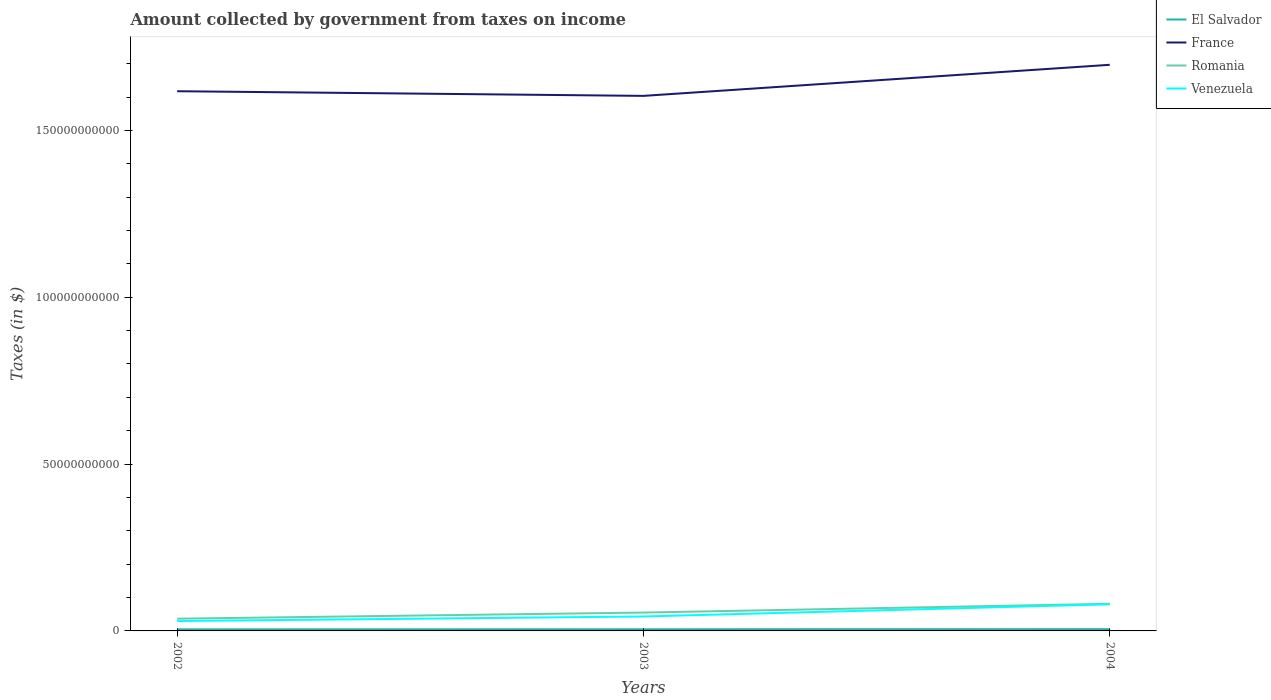Across all years, what is the maximum amount collected by government from taxes on income in El Salvador?
Make the answer very short. 4.71e+08. In which year was the amount collected by government from taxes on income in Romania maximum?
Ensure brevity in your answer.  2002. What is the total amount collected by government from taxes on income in Venezuela in the graph?
Give a very brief answer. -5.02e+09. What is the difference between the highest and the second highest amount collected by government from taxes on income in France?
Your answer should be compact. 9.31e+09. What is the difference between the highest and the lowest amount collected by government from taxes on income in Venezuela?
Give a very brief answer. 1. Is the amount collected by government from taxes on income in Romania strictly greater than the amount collected by government from taxes on income in France over the years?
Provide a short and direct response. Yes. How many lines are there?
Offer a very short reply. 4. How many years are there in the graph?
Offer a very short reply. 3. What is the difference between two consecutive major ticks on the Y-axis?
Ensure brevity in your answer.  5.00e+1. Are the values on the major ticks of Y-axis written in scientific E-notation?
Ensure brevity in your answer.  No. Where does the legend appear in the graph?
Provide a succinct answer. Top right. What is the title of the graph?
Your answer should be compact. Amount collected by government from taxes on income. Does "Brazil" appear as one of the legend labels in the graph?
Keep it short and to the point. No. What is the label or title of the Y-axis?
Offer a very short reply. Taxes (in $). What is the Taxes (in $) in El Salvador in 2002?
Provide a succinct answer. 4.71e+08. What is the Taxes (in $) of France in 2002?
Ensure brevity in your answer.  1.62e+11. What is the Taxes (in $) of Romania in 2002?
Make the answer very short. 3.67e+09. What is the Taxes (in $) in Venezuela in 2002?
Give a very brief answer. 2.96e+09. What is the Taxes (in $) in El Salvador in 2003?
Your answer should be very brief. 4.98e+08. What is the Taxes (in $) in France in 2003?
Make the answer very short. 1.60e+11. What is the Taxes (in $) of Romania in 2003?
Your answer should be very brief. 5.50e+09. What is the Taxes (in $) of Venezuela in 2003?
Your response must be concise. 4.33e+09. What is the Taxes (in $) in El Salvador in 2004?
Provide a short and direct response. 5.25e+08. What is the Taxes (in $) of France in 2004?
Make the answer very short. 1.70e+11. What is the Taxes (in $) in Romania in 2004?
Keep it short and to the point. 8.13e+09. What is the Taxes (in $) of Venezuela in 2004?
Provide a succinct answer. 7.99e+09. Across all years, what is the maximum Taxes (in $) in El Salvador?
Give a very brief answer. 5.25e+08. Across all years, what is the maximum Taxes (in $) of France?
Ensure brevity in your answer.  1.70e+11. Across all years, what is the maximum Taxes (in $) of Romania?
Ensure brevity in your answer.  8.13e+09. Across all years, what is the maximum Taxes (in $) of Venezuela?
Offer a very short reply. 7.99e+09. Across all years, what is the minimum Taxes (in $) in El Salvador?
Ensure brevity in your answer.  4.71e+08. Across all years, what is the minimum Taxes (in $) of France?
Your answer should be very brief. 1.60e+11. Across all years, what is the minimum Taxes (in $) in Romania?
Provide a short and direct response. 3.67e+09. Across all years, what is the minimum Taxes (in $) in Venezuela?
Provide a short and direct response. 2.96e+09. What is the total Taxes (in $) of El Salvador in the graph?
Provide a succinct answer. 1.49e+09. What is the total Taxes (in $) in France in the graph?
Offer a terse response. 4.92e+11. What is the total Taxes (in $) of Romania in the graph?
Provide a short and direct response. 1.73e+1. What is the total Taxes (in $) of Venezuela in the graph?
Offer a very short reply. 1.53e+1. What is the difference between the Taxes (in $) of El Salvador in 2002 and that in 2003?
Provide a short and direct response. -2.67e+07. What is the difference between the Taxes (in $) of France in 2002 and that in 2003?
Your answer should be compact. 1.40e+09. What is the difference between the Taxes (in $) in Romania in 2002 and that in 2003?
Provide a succinct answer. -1.83e+09. What is the difference between the Taxes (in $) of Venezuela in 2002 and that in 2003?
Ensure brevity in your answer.  -1.36e+09. What is the difference between the Taxes (in $) in El Salvador in 2002 and that in 2004?
Ensure brevity in your answer.  -5.35e+07. What is the difference between the Taxes (in $) in France in 2002 and that in 2004?
Ensure brevity in your answer.  -7.92e+09. What is the difference between the Taxes (in $) of Romania in 2002 and that in 2004?
Keep it short and to the point. -4.46e+09. What is the difference between the Taxes (in $) of Venezuela in 2002 and that in 2004?
Your answer should be very brief. -5.02e+09. What is the difference between the Taxes (in $) in El Salvador in 2003 and that in 2004?
Keep it short and to the point. -2.68e+07. What is the difference between the Taxes (in $) of France in 2003 and that in 2004?
Your answer should be compact. -9.31e+09. What is the difference between the Taxes (in $) in Romania in 2003 and that in 2004?
Provide a succinct answer. -2.63e+09. What is the difference between the Taxes (in $) in Venezuela in 2003 and that in 2004?
Your response must be concise. -3.66e+09. What is the difference between the Taxes (in $) of El Salvador in 2002 and the Taxes (in $) of France in 2003?
Your answer should be very brief. -1.60e+11. What is the difference between the Taxes (in $) in El Salvador in 2002 and the Taxes (in $) in Romania in 2003?
Offer a very short reply. -5.03e+09. What is the difference between the Taxes (in $) in El Salvador in 2002 and the Taxes (in $) in Venezuela in 2003?
Make the answer very short. -3.85e+09. What is the difference between the Taxes (in $) in France in 2002 and the Taxes (in $) in Romania in 2003?
Provide a short and direct response. 1.56e+11. What is the difference between the Taxes (in $) of France in 2002 and the Taxes (in $) of Venezuela in 2003?
Keep it short and to the point. 1.57e+11. What is the difference between the Taxes (in $) of Romania in 2002 and the Taxes (in $) of Venezuela in 2003?
Provide a short and direct response. -6.57e+08. What is the difference between the Taxes (in $) in El Salvador in 2002 and the Taxes (in $) in France in 2004?
Offer a very short reply. -1.69e+11. What is the difference between the Taxes (in $) in El Salvador in 2002 and the Taxes (in $) in Romania in 2004?
Your answer should be very brief. -7.66e+09. What is the difference between the Taxes (in $) in El Salvador in 2002 and the Taxes (in $) in Venezuela in 2004?
Offer a terse response. -7.51e+09. What is the difference between the Taxes (in $) in France in 2002 and the Taxes (in $) in Romania in 2004?
Offer a terse response. 1.54e+11. What is the difference between the Taxes (in $) of France in 2002 and the Taxes (in $) of Venezuela in 2004?
Provide a succinct answer. 1.54e+11. What is the difference between the Taxes (in $) in Romania in 2002 and the Taxes (in $) in Venezuela in 2004?
Offer a very short reply. -4.32e+09. What is the difference between the Taxes (in $) in El Salvador in 2003 and the Taxes (in $) in France in 2004?
Your answer should be compact. -1.69e+11. What is the difference between the Taxes (in $) in El Salvador in 2003 and the Taxes (in $) in Romania in 2004?
Provide a succinct answer. -7.63e+09. What is the difference between the Taxes (in $) in El Salvador in 2003 and the Taxes (in $) in Venezuela in 2004?
Make the answer very short. -7.49e+09. What is the difference between the Taxes (in $) in France in 2003 and the Taxes (in $) in Romania in 2004?
Offer a very short reply. 1.52e+11. What is the difference between the Taxes (in $) of France in 2003 and the Taxes (in $) of Venezuela in 2004?
Provide a succinct answer. 1.52e+11. What is the difference between the Taxes (in $) in Romania in 2003 and the Taxes (in $) in Venezuela in 2004?
Keep it short and to the point. -2.48e+09. What is the average Taxes (in $) in El Salvador per year?
Make the answer very short. 4.98e+08. What is the average Taxes (in $) in France per year?
Offer a very short reply. 1.64e+11. What is the average Taxes (in $) of Romania per year?
Make the answer very short. 5.77e+09. What is the average Taxes (in $) in Venezuela per year?
Provide a succinct answer. 5.09e+09. In the year 2002, what is the difference between the Taxes (in $) of El Salvador and Taxes (in $) of France?
Provide a short and direct response. -1.61e+11. In the year 2002, what is the difference between the Taxes (in $) in El Salvador and Taxes (in $) in Romania?
Your answer should be compact. -3.20e+09. In the year 2002, what is the difference between the Taxes (in $) in El Salvador and Taxes (in $) in Venezuela?
Provide a succinct answer. -2.49e+09. In the year 2002, what is the difference between the Taxes (in $) of France and Taxes (in $) of Romania?
Make the answer very short. 1.58e+11. In the year 2002, what is the difference between the Taxes (in $) in France and Taxes (in $) in Venezuela?
Give a very brief answer. 1.59e+11. In the year 2002, what is the difference between the Taxes (in $) of Romania and Taxes (in $) of Venezuela?
Make the answer very short. 7.04e+08. In the year 2003, what is the difference between the Taxes (in $) in El Salvador and Taxes (in $) in France?
Offer a terse response. -1.60e+11. In the year 2003, what is the difference between the Taxes (in $) in El Salvador and Taxes (in $) in Romania?
Your response must be concise. -5.00e+09. In the year 2003, what is the difference between the Taxes (in $) of El Salvador and Taxes (in $) of Venezuela?
Offer a very short reply. -3.83e+09. In the year 2003, what is the difference between the Taxes (in $) in France and Taxes (in $) in Romania?
Your response must be concise. 1.55e+11. In the year 2003, what is the difference between the Taxes (in $) of France and Taxes (in $) of Venezuela?
Provide a short and direct response. 1.56e+11. In the year 2003, what is the difference between the Taxes (in $) of Romania and Taxes (in $) of Venezuela?
Offer a very short reply. 1.18e+09. In the year 2004, what is the difference between the Taxes (in $) of El Salvador and Taxes (in $) of France?
Offer a very short reply. -1.69e+11. In the year 2004, what is the difference between the Taxes (in $) of El Salvador and Taxes (in $) of Romania?
Make the answer very short. -7.60e+09. In the year 2004, what is the difference between the Taxes (in $) of El Salvador and Taxes (in $) of Venezuela?
Your answer should be compact. -7.46e+09. In the year 2004, what is the difference between the Taxes (in $) of France and Taxes (in $) of Romania?
Offer a terse response. 1.62e+11. In the year 2004, what is the difference between the Taxes (in $) of France and Taxes (in $) of Venezuela?
Your response must be concise. 1.62e+11. In the year 2004, what is the difference between the Taxes (in $) of Romania and Taxes (in $) of Venezuela?
Make the answer very short. 1.43e+08. What is the ratio of the Taxes (in $) of El Salvador in 2002 to that in 2003?
Offer a terse response. 0.95. What is the ratio of the Taxes (in $) in France in 2002 to that in 2003?
Keep it short and to the point. 1.01. What is the ratio of the Taxes (in $) in Romania in 2002 to that in 2003?
Make the answer very short. 0.67. What is the ratio of the Taxes (in $) in Venezuela in 2002 to that in 2003?
Your answer should be compact. 0.69. What is the ratio of the Taxes (in $) of El Salvador in 2002 to that in 2004?
Keep it short and to the point. 0.9. What is the ratio of the Taxes (in $) of France in 2002 to that in 2004?
Offer a very short reply. 0.95. What is the ratio of the Taxes (in $) of Romania in 2002 to that in 2004?
Keep it short and to the point. 0.45. What is the ratio of the Taxes (in $) of Venezuela in 2002 to that in 2004?
Provide a short and direct response. 0.37. What is the ratio of the Taxes (in $) in El Salvador in 2003 to that in 2004?
Ensure brevity in your answer.  0.95. What is the ratio of the Taxes (in $) of France in 2003 to that in 2004?
Ensure brevity in your answer.  0.95. What is the ratio of the Taxes (in $) of Romania in 2003 to that in 2004?
Give a very brief answer. 0.68. What is the ratio of the Taxes (in $) of Venezuela in 2003 to that in 2004?
Keep it short and to the point. 0.54. What is the difference between the highest and the second highest Taxes (in $) of El Salvador?
Provide a succinct answer. 2.68e+07. What is the difference between the highest and the second highest Taxes (in $) of France?
Provide a short and direct response. 7.92e+09. What is the difference between the highest and the second highest Taxes (in $) of Romania?
Your answer should be very brief. 2.63e+09. What is the difference between the highest and the second highest Taxes (in $) in Venezuela?
Your answer should be very brief. 3.66e+09. What is the difference between the highest and the lowest Taxes (in $) in El Salvador?
Give a very brief answer. 5.35e+07. What is the difference between the highest and the lowest Taxes (in $) of France?
Offer a terse response. 9.31e+09. What is the difference between the highest and the lowest Taxes (in $) of Romania?
Your response must be concise. 4.46e+09. What is the difference between the highest and the lowest Taxes (in $) of Venezuela?
Offer a very short reply. 5.02e+09. 